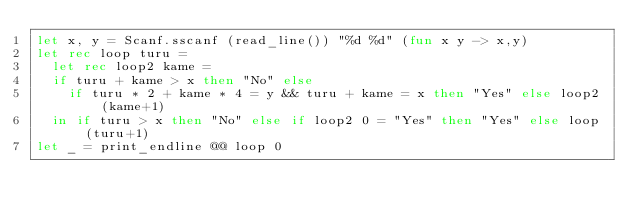<code> <loc_0><loc_0><loc_500><loc_500><_OCaml_>let x, y = Scanf.sscanf (read_line()) "%d %d" (fun x y -> x,y)
let rec loop turu =
  let rec loop2 kame =
  if turu + kame > x then "No" else 
    if turu * 2 + kame * 4 = y && turu + kame = x then "Yes" else loop2 (kame+1)
  in if turu > x then "No" else if loop2 0 = "Yes" then "Yes" else loop (turu+1)
let _ = print_endline @@ loop 0</code> 